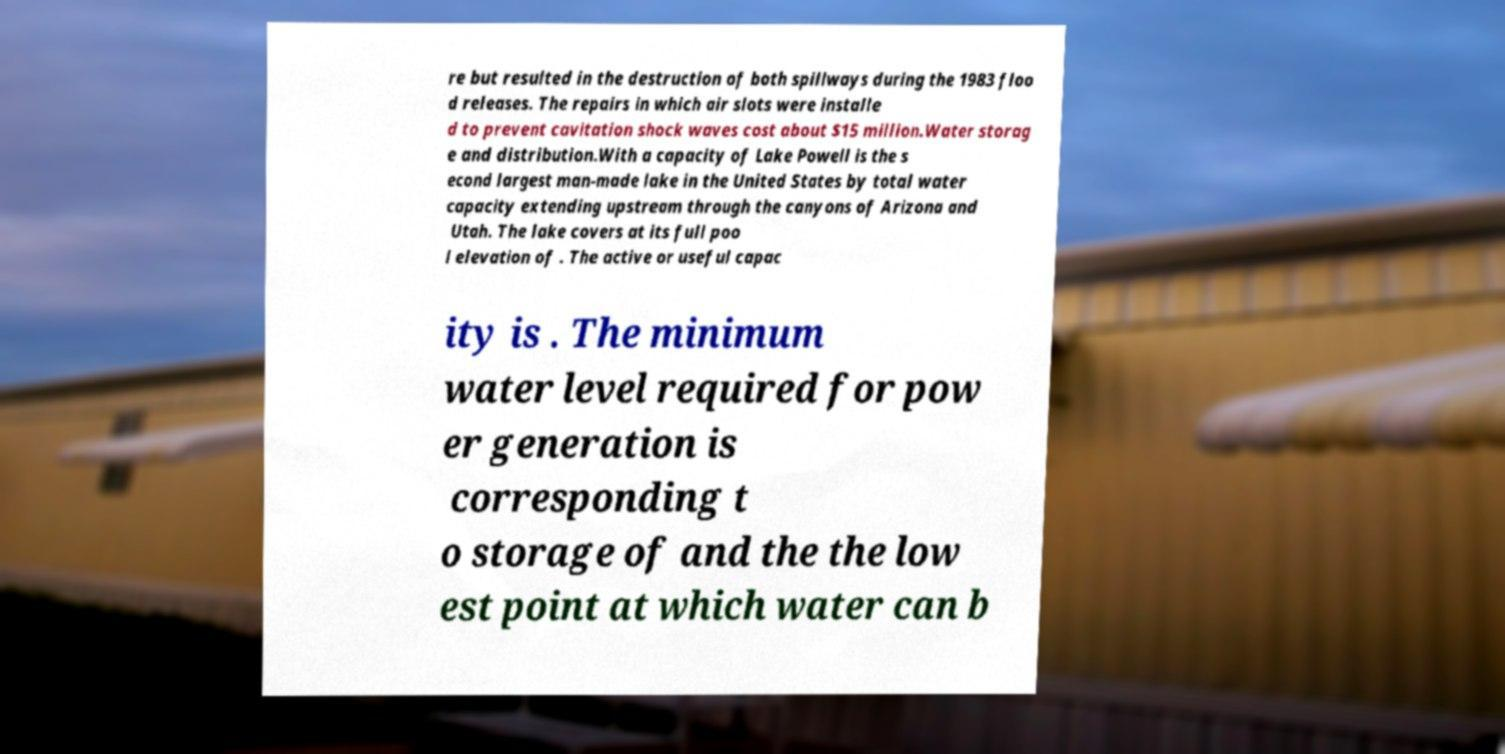Could you extract and type out the text from this image? re but resulted in the destruction of both spillways during the 1983 floo d releases. The repairs in which air slots were installe d to prevent cavitation shock waves cost about $15 million.Water storag e and distribution.With a capacity of Lake Powell is the s econd largest man-made lake in the United States by total water capacity extending upstream through the canyons of Arizona and Utah. The lake covers at its full poo l elevation of . The active or useful capac ity is . The minimum water level required for pow er generation is corresponding t o storage of and the the low est point at which water can b 